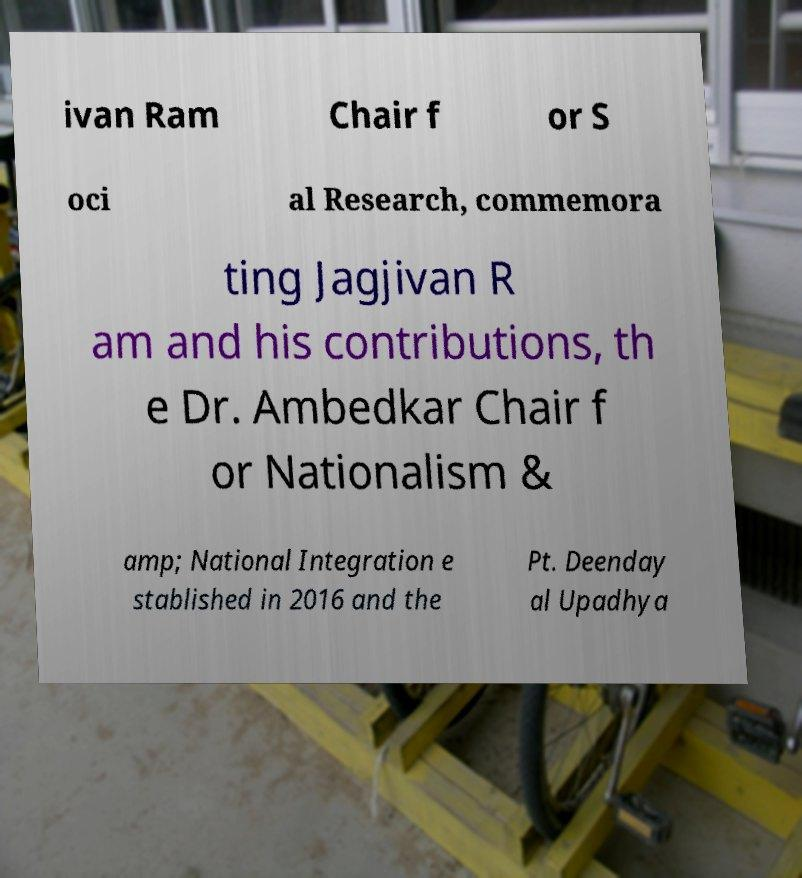Please read and relay the text visible in this image. What does it say? ivan Ram Chair f or S oci al Research, commemora ting Jagjivan R am and his contributions, th e Dr. Ambedkar Chair f or Nationalism & amp; National Integration e stablished in 2016 and the Pt. Deenday al Upadhya 